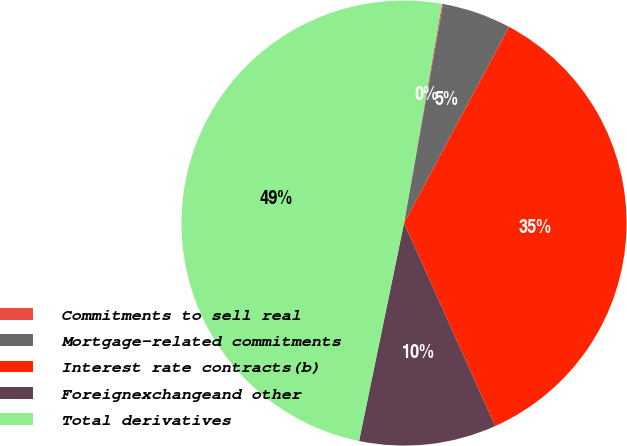Convert chart to OTSL. <chart><loc_0><loc_0><loc_500><loc_500><pie_chart><fcel>Commitments to sell real<fcel>Mortgage-related commitments<fcel>Interest rate contracts(b)<fcel>Foreignexchangeand other<fcel>Total derivatives<nl><fcel>0.08%<fcel>5.02%<fcel>35.46%<fcel>9.96%<fcel>49.49%<nl></chart> 